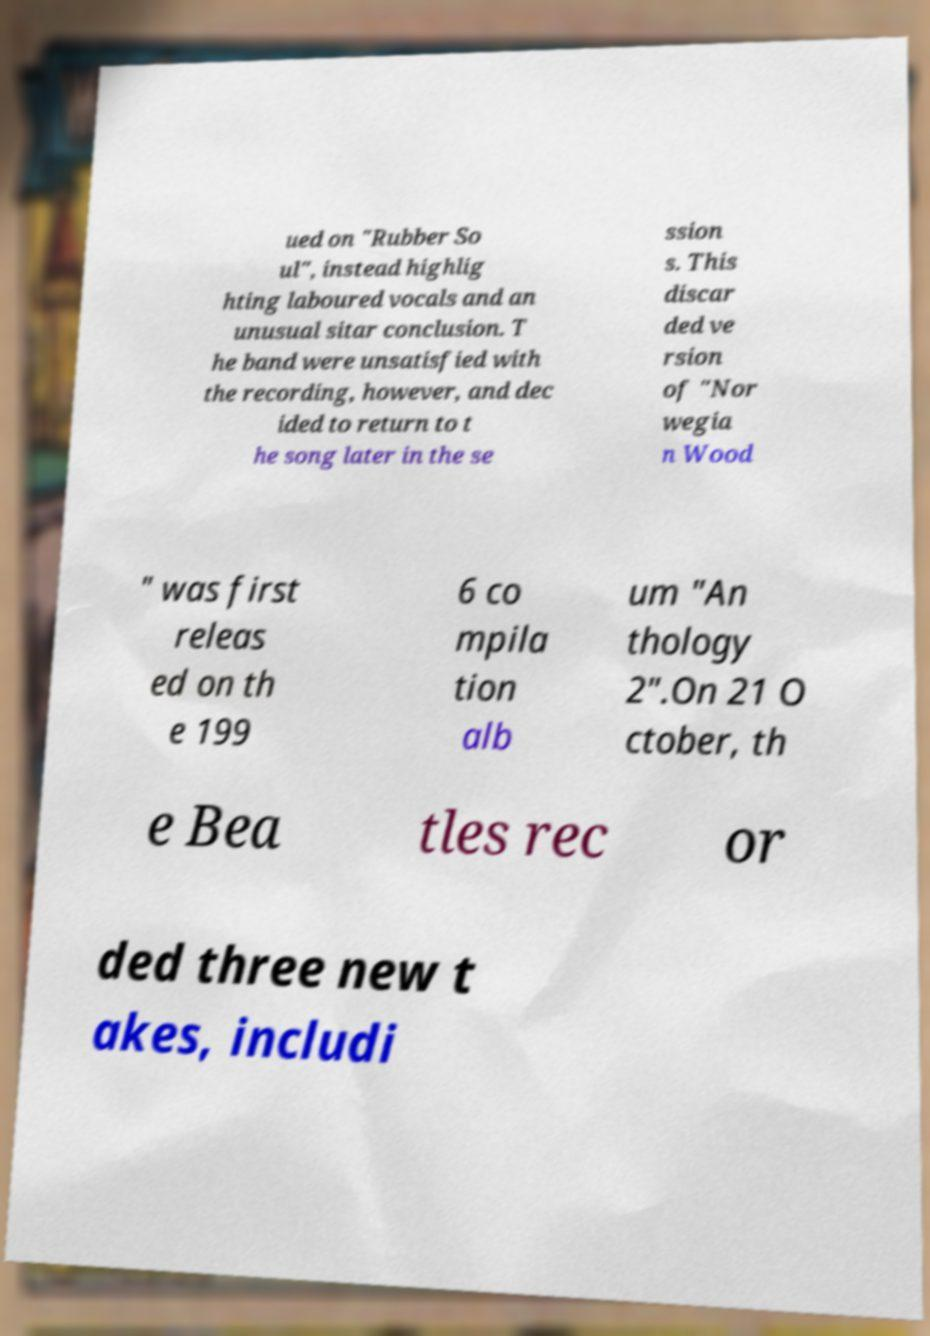Could you assist in decoding the text presented in this image and type it out clearly? ued on "Rubber So ul", instead highlig hting laboured vocals and an unusual sitar conclusion. T he band were unsatisfied with the recording, however, and dec ided to return to t he song later in the se ssion s. This discar ded ve rsion of "Nor wegia n Wood " was first releas ed on th e 199 6 co mpila tion alb um "An thology 2".On 21 O ctober, th e Bea tles rec or ded three new t akes, includi 